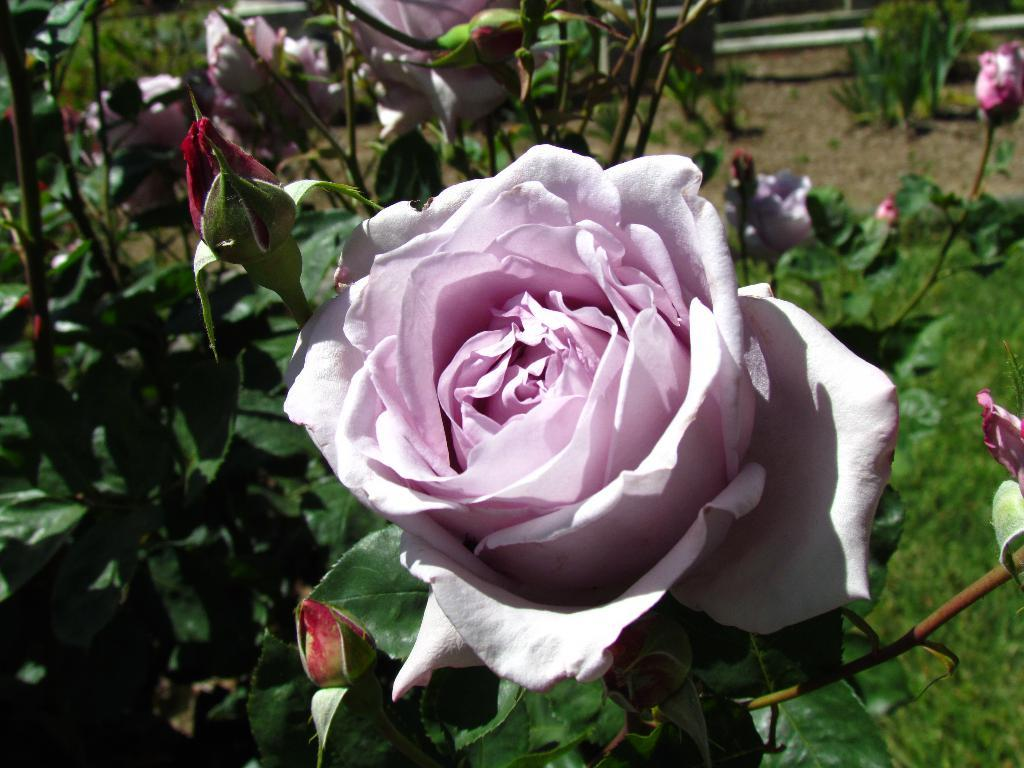What is the main subject in the foreground of the image? There is a flower in the foreground of the image. What can be seen in the background of the image? There are flowers, plants, pipes, and sand visible in the background of the image. What type of vegetation is on the right side of the image? There is grass on the right side of the image. What type of food is the flower cooking in the image? There is no food or cooking activity present in the image; it features a flower in the foreground and various elements in the background. 